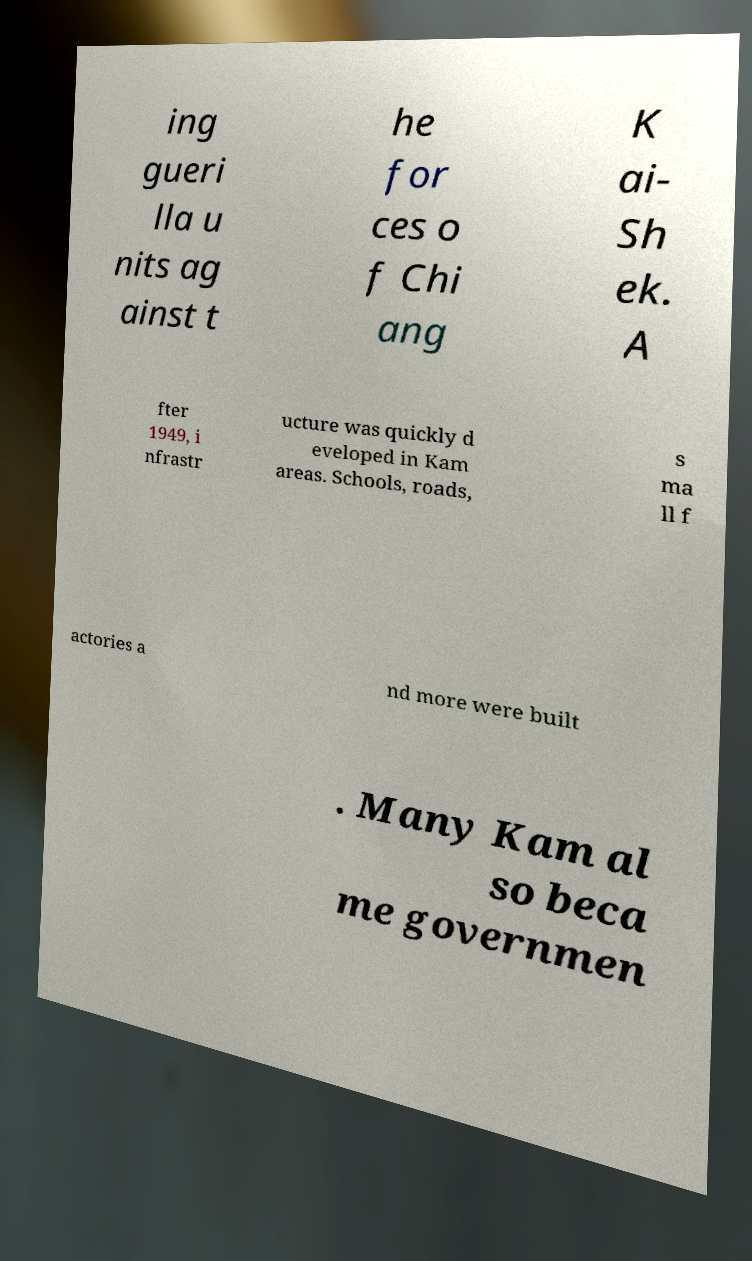Please identify and transcribe the text found in this image. ing gueri lla u nits ag ainst t he for ces o f Chi ang K ai- Sh ek. A fter 1949, i nfrastr ucture was quickly d eveloped in Kam areas. Schools, roads, s ma ll f actories a nd more were built . Many Kam al so beca me governmen 